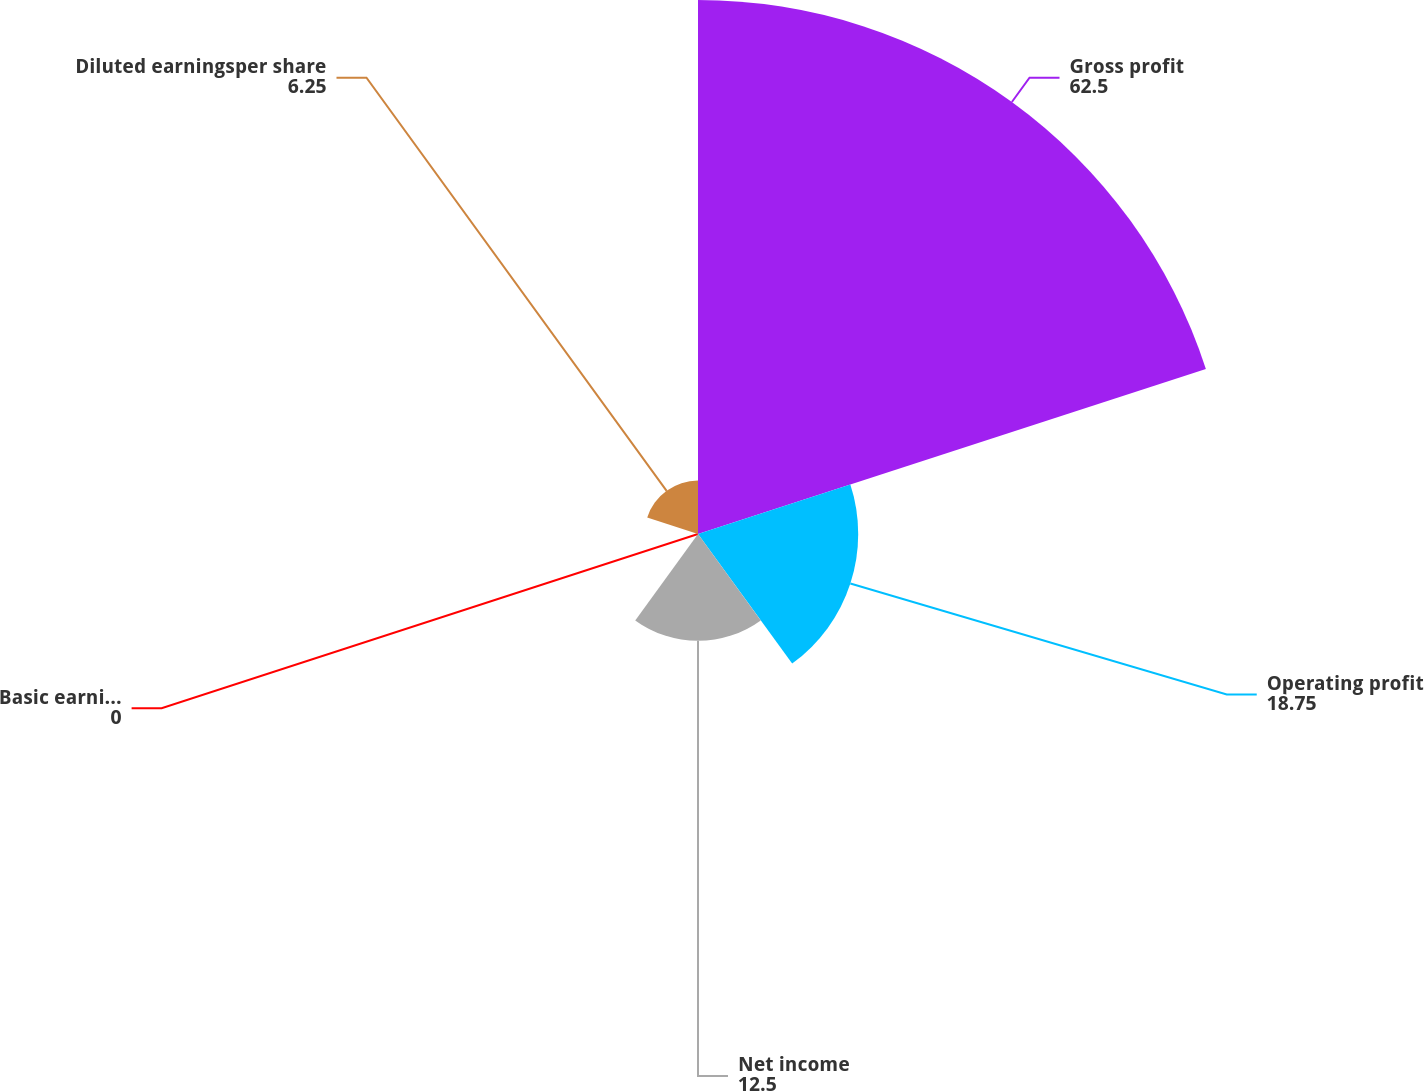<chart> <loc_0><loc_0><loc_500><loc_500><pie_chart><fcel>Gross profit<fcel>Operating profit<fcel>Net income<fcel>Basic earningsper share<fcel>Diluted earningsper share<nl><fcel>62.5%<fcel>18.75%<fcel>12.5%<fcel>0.0%<fcel>6.25%<nl></chart> 